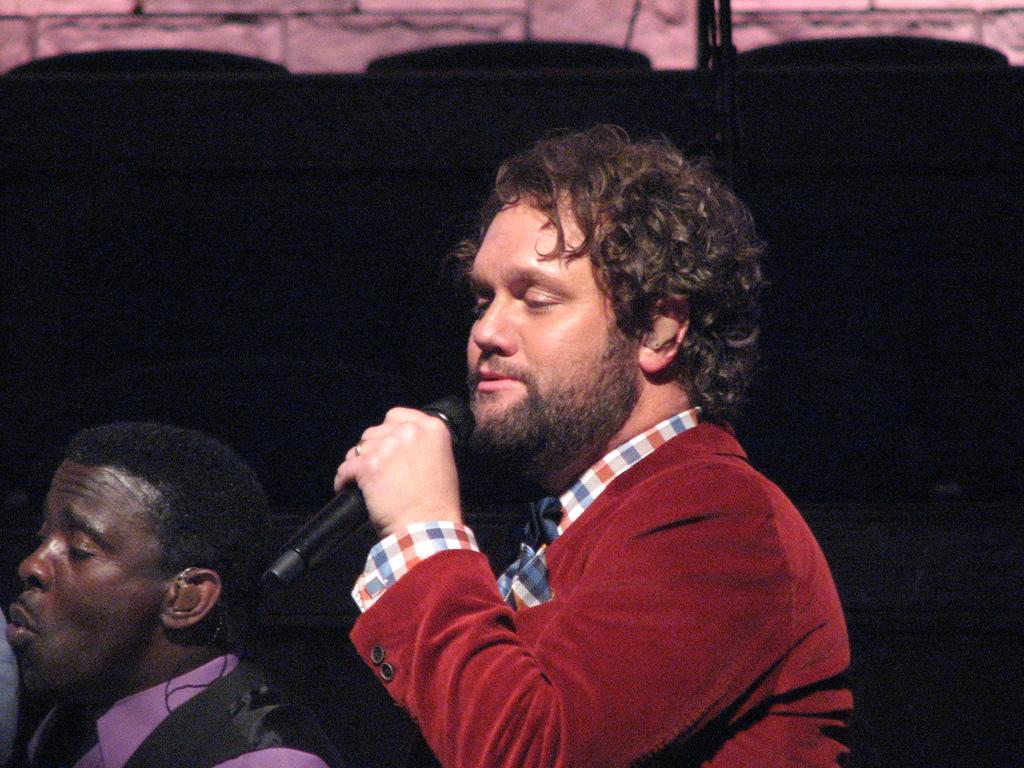Can you describe this image briefly? In this picture we can see two men singing. This man is holding a mike in his hand. Background is dark 